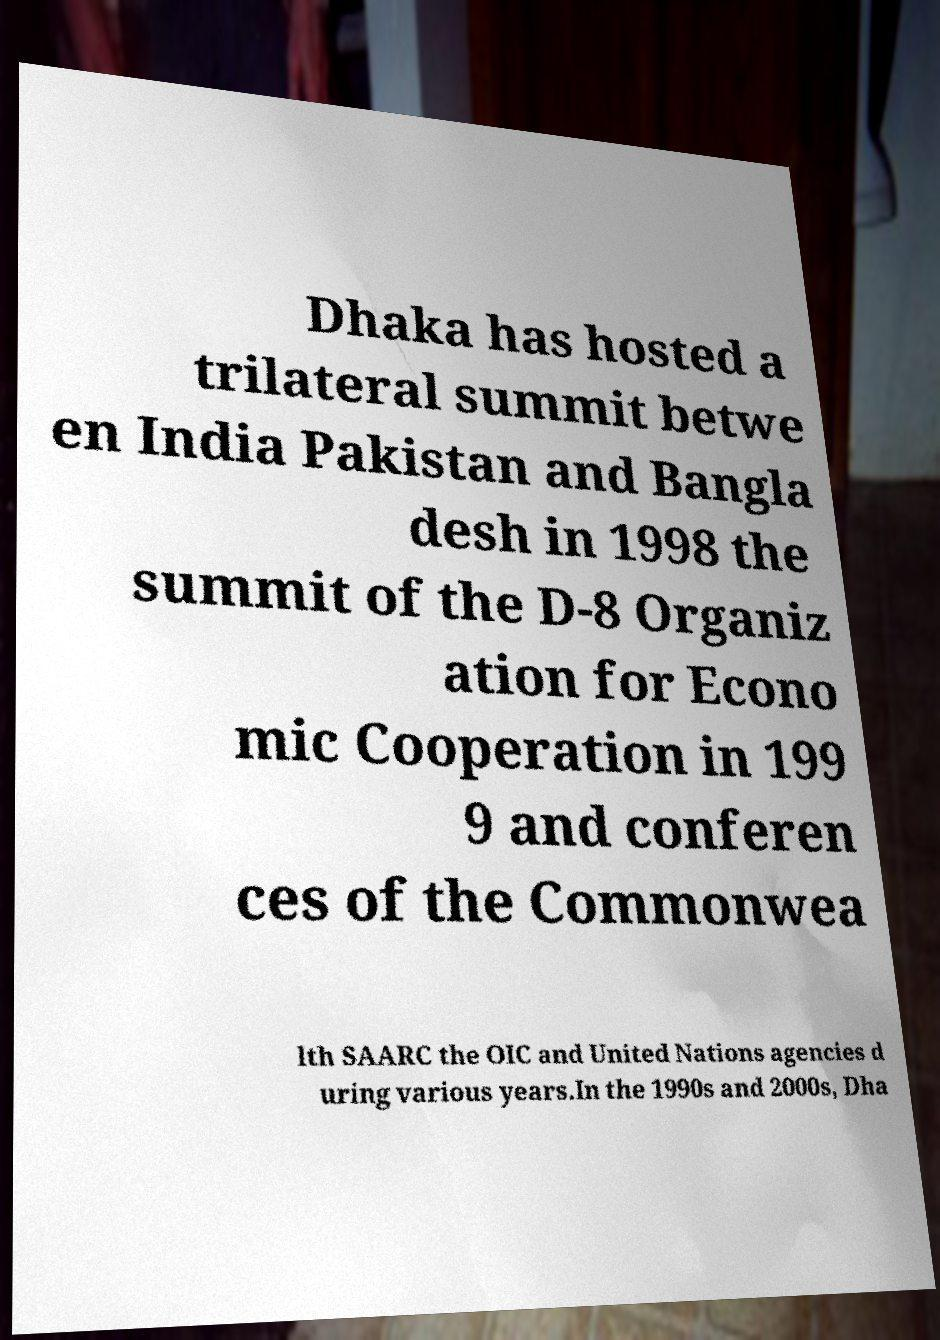Please read and relay the text visible in this image. What does it say? Dhaka has hosted a trilateral summit betwe en India Pakistan and Bangla desh in 1998 the summit of the D-8 Organiz ation for Econo mic Cooperation in 199 9 and conferen ces of the Commonwea lth SAARC the OIC and United Nations agencies d uring various years.In the 1990s and 2000s, Dha 